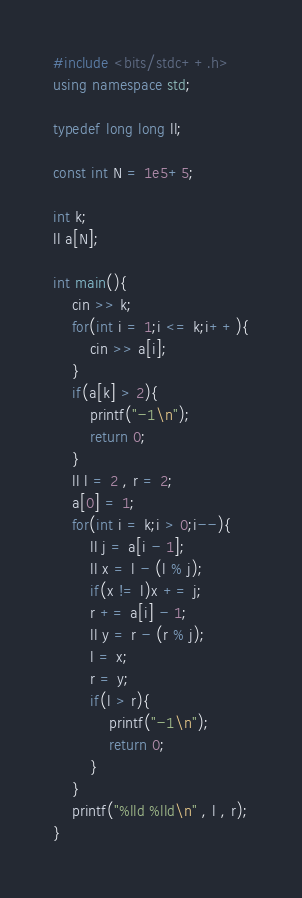Convert code to text. <code><loc_0><loc_0><loc_500><loc_500><_C++_>#include <bits/stdc++.h>
using namespace std;

typedef long long ll;

const int N = 1e5+5;

int k;
ll a[N];

int main(){
	cin >> k;
	for(int i = 1;i <= k;i++){
		cin >> a[i];
	}
	if(a[k] > 2){
		printf("-1\n");
		return 0;
	}
	ll l = 2 , r = 2;
	a[0] = 1;
	for(int i = k;i > 0;i--){
		ll j = a[i - 1];
		ll x = l - (l % j);
		if(x != l)x += j;
		r += a[i] - 1;
		ll y = r - (r % j);
		l = x;
		r = y;
		if(l > r){
			printf("-1\n");
			return 0;
		}
	}
	printf("%lld %lld\n" , l , r);
}</code> 